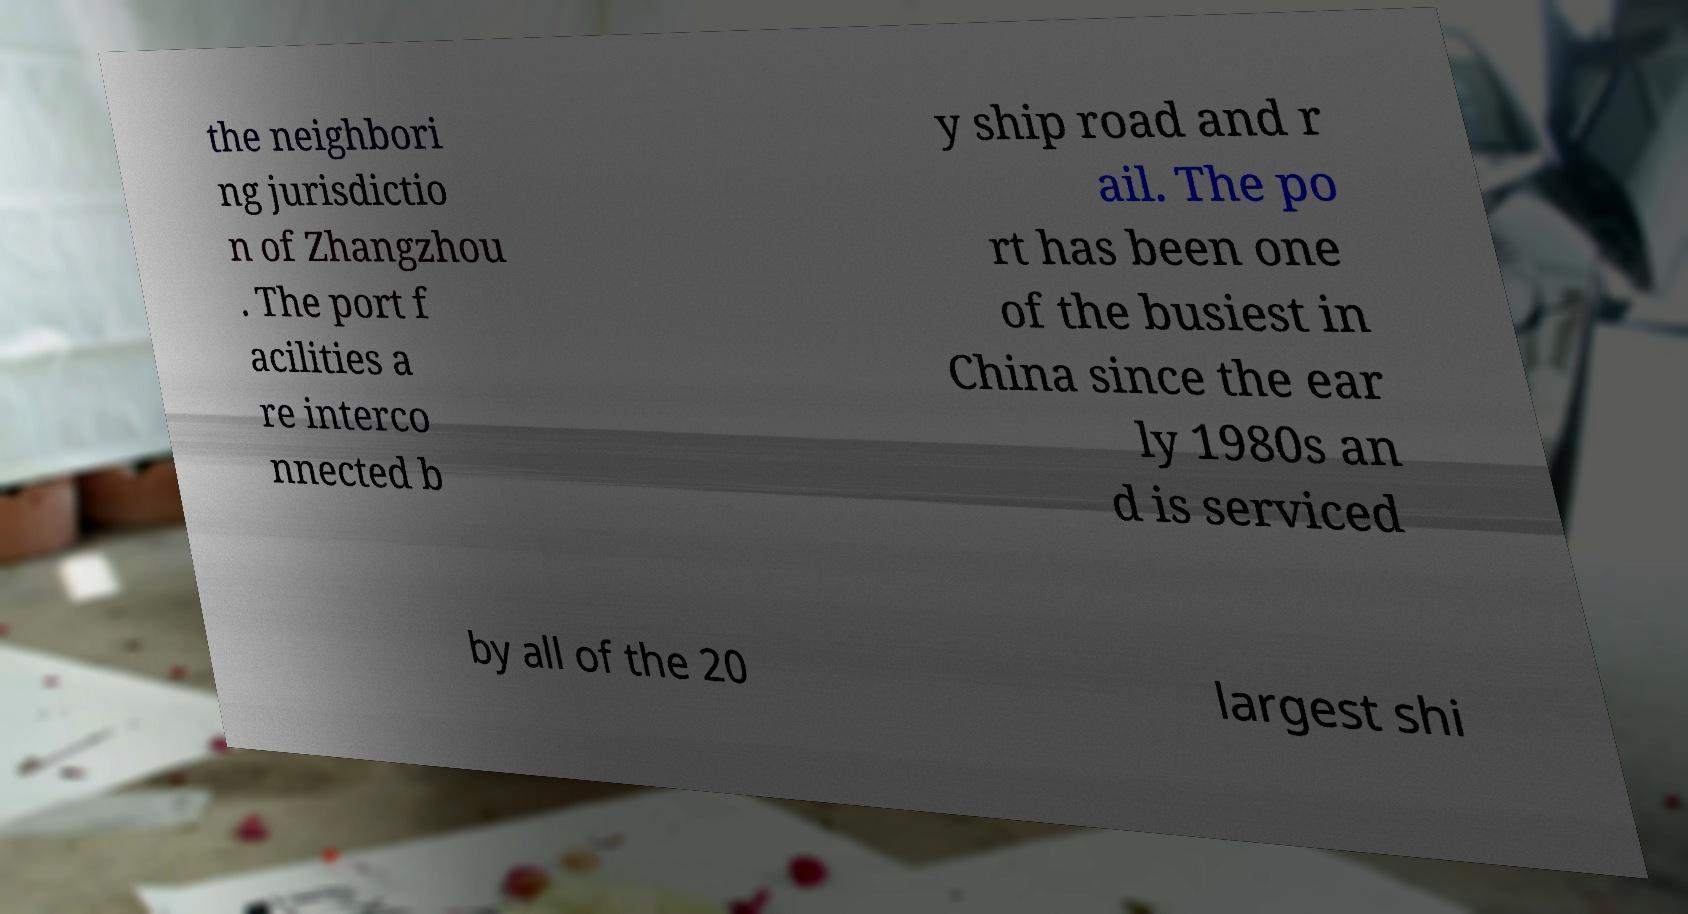Can you read and provide the text displayed in the image?This photo seems to have some interesting text. Can you extract and type it out for me? the neighbori ng jurisdictio n of Zhangzhou . The port f acilities a re interco nnected b y ship road and r ail. The po rt has been one of the busiest in China since the ear ly 1980s an d is serviced by all of the 20 largest shi 